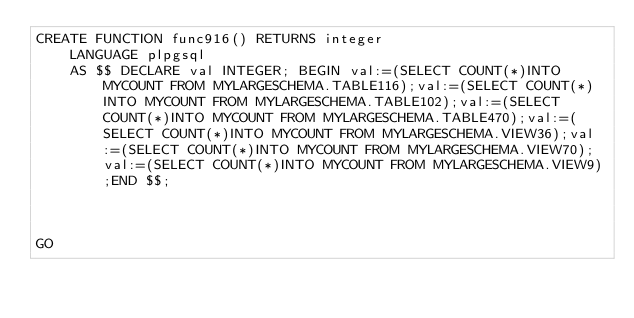Convert code to text. <code><loc_0><loc_0><loc_500><loc_500><_SQL_>CREATE FUNCTION func916() RETURNS integer
    LANGUAGE plpgsql
    AS $$ DECLARE val INTEGER; BEGIN val:=(SELECT COUNT(*)INTO MYCOUNT FROM MYLARGESCHEMA.TABLE116);val:=(SELECT COUNT(*)INTO MYCOUNT FROM MYLARGESCHEMA.TABLE102);val:=(SELECT COUNT(*)INTO MYCOUNT FROM MYLARGESCHEMA.TABLE470);val:=(SELECT COUNT(*)INTO MYCOUNT FROM MYLARGESCHEMA.VIEW36);val:=(SELECT COUNT(*)INTO MYCOUNT FROM MYLARGESCHEMA.VIEW70);val:=(SELECT COUNT(*)INTO MYCOUNT FROM MYLARGESCHEMA.VIEW9);END $$;



GO</code> 